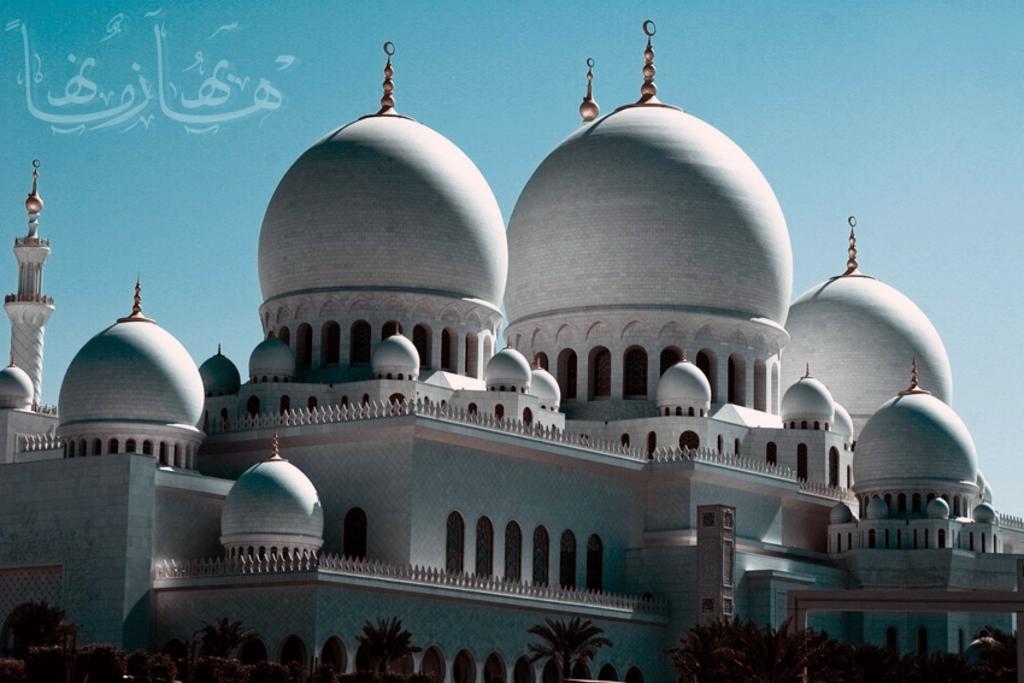Can you describe this image briefly? In this image we can see a building. At the bottom there are trees. In the background there is sky. 